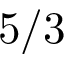Convert formula to latex. <formula><loc_0><loc_0><loc_500><loc_500>5 / 3</formula> 